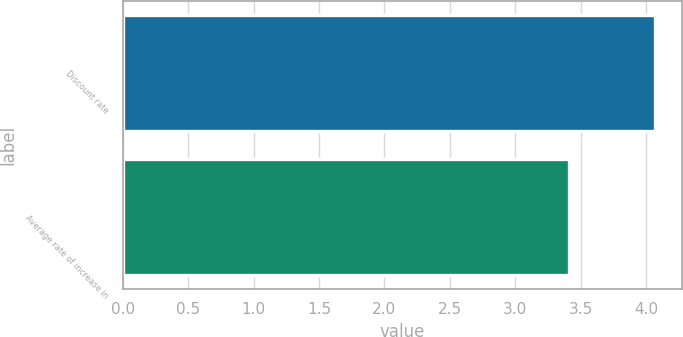<chart> <loc_0><loc_0><loc_500><loc_500><bar_chart><fcel>Discount rate<fcel>Average rate of increase in<nl><fcel>4.07<fcel>3.41<nl></chart> 